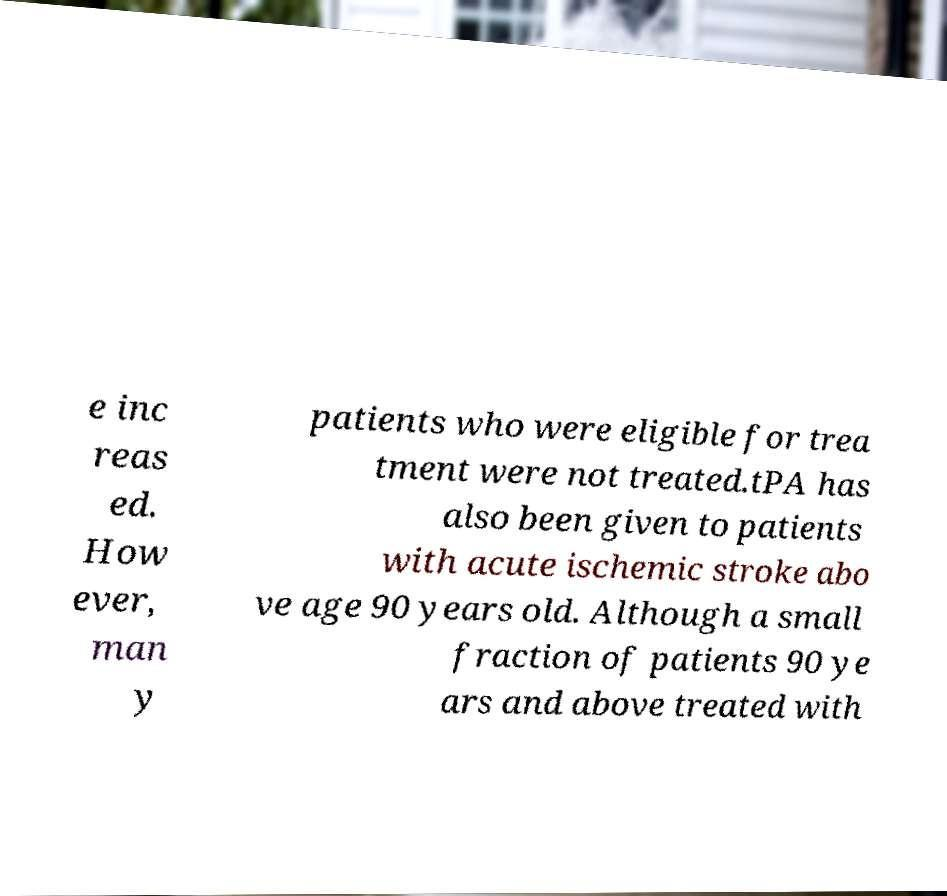There's text embedded in this image that I need extracted. Can you transcribe it verbatim? e inc reas ed. How ever, man y patients who were eligible for trea tment were not treated.tPA has also been given to patients with acute ischemic stroke abo ve age 90 years old. Although a small fraction of patients 90 ye ars and above treated with 